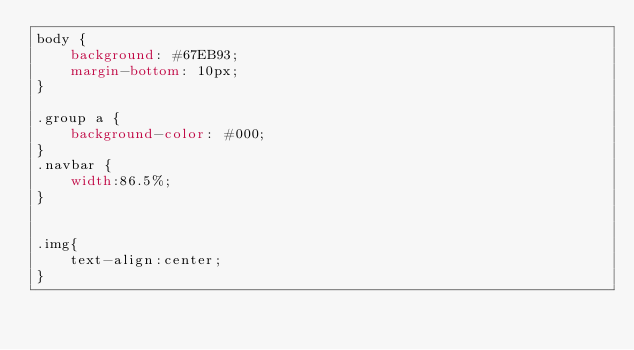Convert code to text. <code><loc_0><loc_0><loc_500><loc_500><_CSS_>body {
    background: #67EB93;
    margin-bottom: 10px;
}

.group a {
    background-color: #000;
}
.navbar {
    width:86.5%;   
}


.img{
    text-align:center;
}</code> 